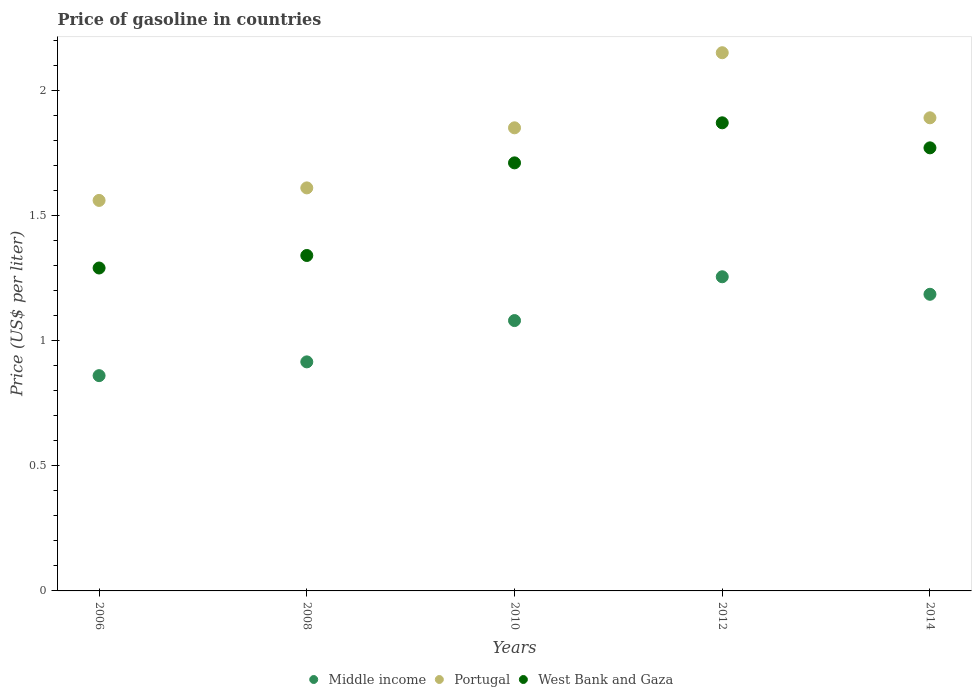How many different coloured dotlines are there?
Your answer should be very brief. 3. What is the price of gasoline in Middle income in 2014?
Your response must be concise. 1.19. Across all years, what is the maximum price of gasoline in Portugal?
Give a very brief answer. 2.15. Across all years, what is the minimum price of gasoline in West Bank and Gaza?
Your response must be concise. 1.29. In which year was the price of gasoline in West Bank and Gaza maximum?
Provide a short and direct response. 2012. What is the total price of gasoline in Middle income in the graph?
Provide a short and direct response. 5.29. What is the difference between the price of gasoline in Portugal in 2006 and that in 2012?
Keep it short and to the point. -0.59. What is the difference between the price of gasoline in Portugal in 2006 and the price of gasoline in West Bank and Gaza in 2014?
Ensure brevity in your answer.  -0.21. What is the average price of gasoline in Portugal per year?
Provide a short and direct response. 1.81. In the year 2014, what is the difference between the price of gasoline in West Bank and Gaza and price of gasoline in Portugal?
Your response must be concise. -0.12. In how many years, is the price of gasoline in West Bank and Gaza greater than 0.5 US$?
Offer a very short reply. 5. What is the ratio of the price of gasoline in Portugal in 2006 to that in 2008?
Make the answer very short. 0.97. Is the difference between the price of gasoline in West Bank and Gaza in 2008 and 2012 greater than the difference between the price of gasoline in Portugal in 2008 and 2012?
Your answer should be very brief. Yes. What is the difference between the highest and the second highest price of gasoline in Middle income?
Your answer should be very brief. 0.07. What is the difference between the highest and the lowest price of gasoline in Middle income?
Provide a short and direct response. 0.39. In how many years, is the price of gasoline in West Bank and Gaza greater than the average price of gasoline in West Bank and Gaza taken over all years?
Your answer should be very brief. 3. Is the sum of the price of gasoline in Portugal in 2008 and 2014 greater than the maximum price of gasoline in West Bank and Gaza across all years?
Keep it short and to the point. Yes. Is it the case that in every year, the sum of the price of gasoline in Middle income and price of gasoline in Portugal  is greater than the price of gasoline in West Bank and Gaza?
Provide a succinct answer. Yes. Does the price of gasoline in Middle income monotonically increase over the years?
Ensure brevity in your answer.  No. Is the price of gasoline in Portugal strictly greater than the price of gasoline in West Bank and Gaza over the years?
Your response must be concise. Yes. Is the price of gasoline in West Bank and Gaza strictly less than the price of gasoline in Middle income over the years?
Offer a terse response. No. How many years are there in the graph?
Offer a terse response. 5. Does the graph contain any zero values?
Keep it short and to the point. No. Where does the legend appear in the graph?
Provide a succinct answer. Bottom center. How many legend labels are there?
Give a very brief answer. 3. What is the title of the graph?
Make the answer very short. Price of gasoline in countries. What is the label or title of the Y-axis?
Keep it short and to the point. Price (US$ per liter). What is the Price (US$ per liter) of Middle income in 2006?
Offer a terse response. 0.86. What is the Price (US$ per liter) in Portugal in 2006?
Offer a very short reply. 1.56. What is the Price (US$ per liter) of West Bank and Gaza in 2006?
Your answer should be very brief. 1.29. What is the Price (US$ per liter) of Middle income in 2008?
Your answer should be very brief. 0.92. What is the Price (US$ per liter) in Portugal in 2008?
Your response must be concise. 1.61. What is the Price (US$ per liter) in West Bank and Gaza in 2008?
Offer a terse response. 1.34. What is the Price (US$ per liter) in Portugal in 2010?
Make the answer very short. 1.85. What is the Price (US$ per liter) in West Bank and Gaza in 2010?
Your response must be concise. 1.71. What is the Price (US$ per liter) of Middle income in 2012?
Make the answer very short. 1.25. What is the Price (US$ per liter) of Portugal in 2012?
Your answer should be very brief. 2.15. What is the Price (US$ per liter) in West Bank and Gaza in 2012?
Offer a very short reply. 1.87. What is the Price (US$ per liter) in Middle income in 2014?
Your answer should be very brief. 1.19. What is the Price (US$ per liter) of Portugal in 2014?
Ensure brevity in your answer.  1.89. What is the Price (US$ per liter) of West Bank and Gaza in 2014?
Keep it short and to the point. 1.77. Across all years, what is the maximum Price (US$ per liter) in Middle income?
Provide a short and direct response. 1.25. Across all years, what is the maximum Price (US$ per liter) of Portugal?
Provide a succinct answer. 2.15. Across all years, what is the maximum Price (US$ per liter) of West Bank and Gaza?
Offer a very short reply. 1.87. Across all years, what is the minimum Price (US$ per liter) of Middle income?
Your answer should be very brief. 0.86. Across all years, what is the minimum Price (US$ per liter) in Portugal?
Your answer should be very brief. 1.56. Across all years, what is the minimum Price (US$ per liter) in West Bank and Gaza?
Keep it short and to the point. 1.29. What is the total Price (US$ per liter) of Middle income in the graph?
Your answer should be very brief. 5.29. What is the total Price (US$ per liter) of Portugal in the graph?
Your response must be concise. 9.06. What is the total Price (US$ per liter) in West Bank and Gaza in the graph?
Your response must be concise. 7.98. What is the difference between the Price (US$ per liter) of Middle income in 2006 and that in 2008?
Ensure brevity in your answer.  -0.06. What is the difference between the Price (US$ per liter) in Middle income in 2006 and that in 2010?
Make the answer very short. -0.22. What is the difference between the Price (US$ per liter) in Portugal in 2006 and that in 2010?
Keep it short and to the point. -0.29. What is the difference between the Price (US$ per liter) in West Bank and Gaza in 2006 and that in 2010?
Offer a terse response. -0.42. What is the difference between the Price (US$ per liter) in Middle income in 2006 and that in 2012?
Keep it short and to the point. -0.4. What is the difference between the Price (US$ per liter) of Portugal in 2006 and that in 2012?
Keep it short and to the point. -0.59. What is the difference between the Price (US$ per liter) in West Bank and Gaza in 2006 and that in 2012?
Your response must be concise. -0.58. What is the difference between the Price (US$ per liter) in Middle income in 2006 and that in 2014?
Provide a short and direct response. -0.33. What is the difference between the Price (US$ per liter) of Portugal in 2006 and that in 2014?
Ensure brevity in your answer.  -0.33. What is the difference between the Price (US$ per liter) in West Bank and Gaza in 2006 and that in 2014?
Ensure brevity in your answer.  -0.48. What is the difference between the Price (US$ per liter) in Middle income in 2008 and that in 2010?
Ensure brevity in your answer.  -0.17. What is the difference between the Price (US$ per liter) in Portugal in 2008 and that in 2010?
Provide a succinct answer. -0.24. What is the difference between the Price (US$ per liter) in West Bank and Gaza in 2008 and that in 2010?
Keep it short and to the point. -0.37. What is the difference between the Price (US$ per liter) of Middle income in 2008 and that in 2012?
Your response must be concise. -0.34. What is the difference between the Price (US$ per liter) in Portugal in 2008 and that in 2012?
Your answer should be very brief. -0.54. What is the difference between the Price (US$ per liter) in West Bank and Gaza in 2008 and that in 2012?
Your answer should be compact. -0.53. What is the difference between the Price (US$ per liter) of Middle income in 2008 and that in 2014?
Keep it short and to the point. -0.27. What is the difference between the Price (US$ per liter) in Portugal in 2008 and that in 2014?
Provide a succinct answer. -0.28. What is the difference between the Price (US$ per liter) of West Bank and Gaza in 2008 and that in 2014?
Your response must be concise. -0.43. What is the difference between the Price (US$ per liter) of Middle income in 2010 and that in 2012?
Your answer should be compact. -0.17. What is the difference between the Price (US$ per liter) in Portugal in 2010 and that in 2012?
Offer a terse response. -0.3. What is the difference between the Price (US$ per liter) in West Bank and Gaza in 2010 and that in 2012?
Offer a terse response. -0.16. What is the difference between the Price (US$ per liter) of Middle income in 2010 and that in 2014?
Keep it short and to the point. -0.1. What is the difference between the Price (US$ per liter) of Portugal in 2010 and that in 2014?
Provide a short and direct response. -0.04. What is the difference between the Price (US$ per liter) in West Bank and Gaza in 2010 and that in 2014?
Ensure brevity in your answer.  -0.06. What is the difference between the Price (US$ per liter) in Middle income in 2012 and that in 2014?
Your answer should be very brief. 0.07. What is the difference between the Price (US$ per liter) in Portugal in 2012 and that in 2014?
Give a very brief answer. 0.26. What is the difference between the Price (US$ per liter) in West Bank and Gaza in 2012 and that in 2014?
Provide a short and direct response. 0.1. What is the difference between the Price (US$ per liter) of Middle income in 2006 and the Price (US$ per liter) of Portugal in 2008?
Make the answer very short. -0.75. What is the difference between the Price (US$ per liter) of Middle income in 2006 and the Price (US$ per liter) of West Bank and Gaza in 2008?
Provide a short and direct response. -0.48. What is the difference between the Price (US$ per liter) in Portugal in 2006 and the Price (US$ per liter) in West Bank and Gaza in 2008?
Offer a terse response. 0.22. What is the difference between the Price (US$ per liter) of Middle income in 2006 and the Price (US$ per liter) of Portugal in 2010?
Offer a very short reply. -0.99. What is the difference between the Price (US$ per liter) in Middle income in 2006 and the Price (US$ per liter) in West Bank and Gaza in 2010?
Give a very brief answer. -0.85. What is the difference between the Price (US$ per liter) in Portugal in 2006 and the Price (US$ per liter) in West Bank and Gaza in 2010?
Provide a succinct answer. -0.15. What is the difference between the Price (US$ per liter) in Middle income in 2006 and the Price (US$ per liter) in Portugal in 2012?
Provide a short and direct response. -1.29. What is the difference between the Price (US$ per liter) in Middle income in 2006 and the Price (US$ per liter) in West Bank and Gaza in 2012?
Ensure brevity in your answer.  -1.01. What is the difference between the Price (US$ per liter) in Portugal in 2006 and the Price (US$ per liter) in West Bank and Gaza in 2012?
Your answer should be compact. -0.31. What is the difference between the Price (US$ per liter) in Middle income in 2006 and the Price (US$ per liter) in Portugal in 2014?
Provide a succinct answer. -1.03. What is the difference between the Price (US$ per liter) in Middle income in 2006 and the Price (US$ per liter) in West Bank and Gaza in 2014?
Give a very brief answer. -0.91. What is the difference between the Price (US$ per liter) of Portugal in 2006 and the Price (US$ per liter) of West Bank and Gaza in 2014?
Keep it short and to the point. -0.21. What is the difference between the Price (US$ per liter) in Middle income in 2008 and the Price (US$ per liter) in Portugal in 2010?
Your answer should be very brief. -0.94. What is the difference between the Price (US$ per liter) in Middle income in 2008 and the Price (US$ per liter) in West Bank and Gaza in 2010?
Provide a succinct answer. -0.8. What is the difference between the Price (US$ per liter) of Portugal in 2008 and the Price (US$ per liter) of West Bank and Gaza in 2010?
Your answer should be compact. -0.1. What is the difference between the Price (US$ per liter) of Middle income in 2008 and the Price (US$ per liter) of Portugal in 2012?
Give a very brief answer. -1.24. What is the difference between the Price (US$ per liter) of Middle income in 2008 and the Price (US$ per liter) of West Bank and Gaza in 2012?
Offer a very short reply. -0.95. What is the difference between the Price (US$ per liter) of Portugal in 2008 and the Price (US$ per liter) of West Bank and Gaza in 2012?
Keep it short and to the point. -0.26. What is the difference between the Price (US$ per liter) in Middle income in 2008 and the Price (US$ per liter) in Portugal in 2014?
Your answer should be very brief. -0.97. What is the difference between the Price (US$ per liter) of Middle income in 2008 and the Price (US$ per liter) of West Bank and Gaza in 2014?
Provide a succinct answer. -0.85. What is the difference between the Price (US$ per liter) of Portugal in 2008 and the Price (US$ per liter) of West Bank and Gaza in 2014?
Make the answer very short. -0.16. What is the difference between the Price (US$ per liter) of Middle income in 2010 and the Price (US$ per liter) of Portugal in 2012?
Your response must be concise. -1.07. What is the difference between the Price (US$ per liter) of Middle income in 2010 and the Price (US$ per liter) of West Bank and Gaza in 2012?
Offer a terse response. -0.79. What is the difference between the Price (US$ per liter) in Portugal in 2010 and the Price (US$ per liter) in West Bank and Gaza in 2012?
Keep it short and to the point. -0.02. What is the difference between the Price (US$ per liter) of Middle income in 2010 and the Price (US$ per liter) of Portugal in 2014?
Ensure brevity in your answer.  -0.81. What is the difference between the Price (US$ per liter) of Middle income in 2010 and the Price (US$ per liter) of West Bank and Gaza in 2014?
Your response must be concise. -0.69. What is the difference between the Price (US$ per liter) in Portugal in 2010 and the Price (US$ per liter) in West Bank and Gaza in 2014?
Offer a very short reply. 0.08. What is the difference between the Price (US$ per liter) in Middle income in 2012 and the Price (US$ per liter) in Portugal in 2014?
Your answer should be very brief. -0.64. What is the difference between the Price (US$ per liter) of Middle income in 2012 and the Price (US$ per liter) of West Bank and Gaza in 2014?
Offer a very short reply. -0.52. What is the difference between the Price (US$ per liter) of Portugal in 2012 and the Price (US$ per liter) of West Bank and Gaza in 2014?
Your response must be concise. 0.38. What is the average Price (US$ per liter) in Middle income per year?
Offer a very short reply. 1.06. What is the average Price (US$ per liter) of Portugal per year?
Ensure brevity in your answer.  1.81. What is the average Price (US$ per liter) of West Bank and Gaza per year?
Offer a very short reply. 1.6. In the year 2006, what is the difference between the Price (US$ per liter) in Middle income and Price (US$ per liter) in Portugal?
Provide a succinct answer. -0.7. In the year 2006, what is the difference between the Price (US$ per liter) in Middle income and Price (US$ per liter) in West Bank and Gaza?
Your answer should be very brief. -0.43. In the year 2006, what is the difference between the Price (US$ per liter) in Portugal and Price (US$ per liter) in West Bank and Gaza?
Keep it short and to the point. 0.27. In the year 2008, what is the difference between the Price (US$ per liter) of Middle income and Price (US$ per liter) of Portugal?
Your answer should be very brief. -0.69. In the year 2008, what is the difference between the Price (US$ per liter) of Middle income and Price (US$ per liter) of West Bank and Gaza?
Give a very brief answer. -0.42. In the year 2008, what is the difference between the Price (US$ per liter) in Portugal and Price (US$ per liter) in West Bank and Gaza?
Provide a succinct answer. 0.27. In the year 2010, what is the difference between the Price (US$ per liter) of Middle income and Price (US$ per liter) of Portugal?
Give a very brief answer. -0.77. In the year 2010, what is the difference between the Price (US$ per liter) in Middle income and Price (US$ per liter) in West Bank and Gaza?
Provide a succinct answer. -0.63. In the year 2010, what is the difference between the Price (US$ per liter) in Portugal and Price (US$ per liter) in West Bank and Gaza?
Give a very brief answer. 0.14. In the year 2012, what is the difference between the Price (US$ per liter) of Middle income and Price (US$ per liter) of Portugal?
Give a very brief answer. -0.9. In the year 2012, what is the difference between the Price (US$ per liter) of Middle income and Price (US$ per liter) of West Bank and Gaza?
Your response must be concise. -0.61. In the year 2012, what is the difference between the Price (US$ per liter) in Portugal and Price (US$ per liter) in West Bank and Gaza?
Provide a short and direct response. 0.28. In the year 2014, what is the difference between the Price (US$ per liter) in Middle income and Price (US$ per liter) in Portugal?
Provide a succinct answer. -0.7. In the year 2014, what is the difference between the Price (US$ per liter) of Middle income and Price (US$ per liter) of West Bank and Gaza?
Make the answer very short. -0.58. In the year 2014, what is the difference between the Price (US$ per liter) in Portugal and Price (US$ per liter) in West Bank and Gaza?
Provide a succinct answer. 0.12. What is the ratio of the Price (US$ per liter) in Middle income in 2006 to that in 2008?
Offer a very short reply. 0.94. What is the ratio of the Price (US$ per liter) in Portugal in 2006 to that in 2008?
Make the answer very short. 0.97. What is the ratio of the Price (US$ per liter) in West Bank and Gaza in 2006 to that in 2008?
Your answer should be very brief. 0.96. What is the ratio of the Price (US$ per liter) in Middle income in 2006 to that in 2010?
Ensure brevity in your answer.  0.8. What is the ratio of the Price (US$ per liter) of Portugal in 2006 to that in 2010?
Your answer should be compact. 0.84. What is the ratio of the Price (US$ per liter) in West Bank and Gaza in 2006 to that in 2010?
Your response must be concise. 0.75. What is the ratio of the Price (US$ per liter) of Middle income in 2006 to that in 2012?
Ensure brevity in your answer.  0.69. What is the ratio of the Price (US$ per liter) of Portugal in 2006 to that in 2012?
Make the answer very short. 0.73. What is the ratio of the Price (US$ per liter) in West Bank and Gaza in 2006 to that in 2012?
Offer a terse response. 0.69. What is the ratio of the Price (US$ per liter) of Middle income in 2006 to that in 2014?
Provide a succinct answer. 0.73. What is the ratio of the Price (US$ per liter) of Portugal in 2006 to that in 2014?
Your answer should be very brief. 0.83. What is the ratio of the Price (US$ per liter) in West Bank and Gaza in 2006 to that in 2014?
Offer a terse response. 0.73. What is the ratio of the Price (US$ per liter) of Middle income in 2008 to that in 2010?
Make the answer very short. 0.85. What is the ratio of the Price (US$ per liter) of Portugal in 2008 to that in 2010?
Your response must be concise. 0.87. What is the ratio of the Price (US$ per liter) of West Bank and Gaza in 2008 to that in 2010?
Ensure brevity in your answer.  0.78. What is the ratio of the Price (US$ per liter) of Middle income in 2008 to that in 2012?
Your answer should be very brief. 0.73. What is the ratio of the Price (US$ per liter) in Portugal in 2008 to that in 2012?
Offer a very short reply. 0.75. What is the ratio of the Price (US$ per liter) in West Bank and Gaza in 2008 to that in 2012?
Your answer should be very brief. 0.72. What is the ratio of the Price (US$ per liter) in Middle income in 2008 to that in 2014?
Give a very brief answer. 0.77. What is the ratio of the Price (US$ per liter) in Portugal in 2008 to that in 2014?
Your answer should be compact. 0.85. What is the ratio of the Price (US$ per liter) of West Bank and Gaza in 2008 to that in 2014?
Ensure brevity in your answer.  0.76. What is the ratio of the Price (US$ per liter) in Middle income in 2010 to that in 2012?
Offer a terse response. 0.86. What is the ratio of the Price (US$ per liter) in Portugal in 2010 to that in 2012?
Provide a succinct answer. 0.86. What is the ratio of the Price (US$ per liter) of West Bank and Gaza in 2010 to that in 2012?
Give a very brief answer. 0.91. What is the ratio of the Price (US$ per liter) in Middle income in 2010 to that in 2014?
Your response must be concise. 0.91. What is the ratio of the Price (US$ per liter) in Portugal in 2010 to that in 2014?
Keep it short and to the point. 0.98. What is the ratio of the Price (US$ per liter) in West Bank and Gaza in 2010 to that in 2014?
Give a very brief answer. 0.97. What is the ratio of the Price (US$ per liter) of Middle income in 2012 to that in 2014?
Your response must be concise. 1.06. What is the ratio of the Price (US$ per liter) of Portugal in 2012 to that in 2014?
Your response must be concise. 1.14. What is the ratio of the Price (US$ per liter) in West Bank and Gaza in 2012 to that in 2014?
Your answer should be very brief. 1.06. What is the difference between the highest and the second highest Price (US$ per liter) of Middle income?
Your answer should be compact. 0.07. What is the difference between the highest and the second highest Price (US$ per liter) in Portugal?
Your answer should be compact. 0.26. What is the difference between the highest and the lowest Price (US$ per liter) of Middle income?
Provide a short and direct response. 0.4. What is the difference between the highest and the lowest Price (US$ per liter) of Portugal?
Your answer should be compact. 0.59. What is the difference between the highest and the lowest Price (US$ per liter) in West Bank and Gaza?
Make the answer very short. 0.58. 